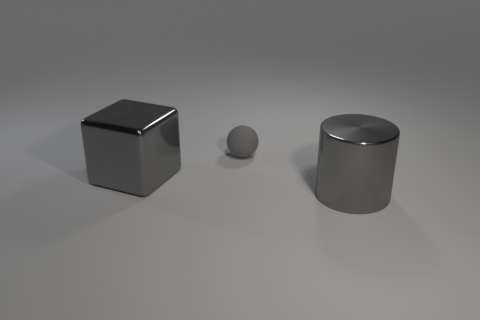Add 3 tiny gray rubber objects. How many objects exist? 6 Subtract all spheres. How many objects are left? 2 Subtract all big gray metal blocks. Subtract all big purple rubber balls. How many objects are left? 2 Add 1 large gray shiny objects. How many large gray shiny objects are left? 3 Add 2 small green things. How many small green things exist? 2 Subtract 1 gray balls. How many objects are left? 2 